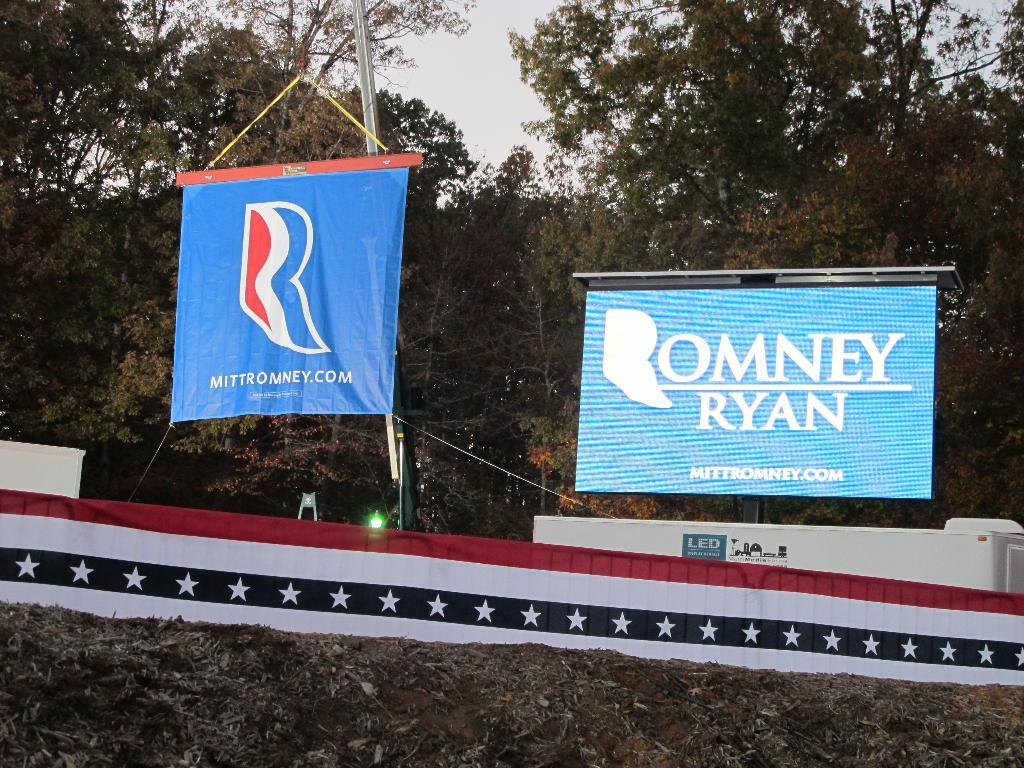<image>
Write a terse but informative summary of the picture. A blue sign showing support for Romney and Ryan is on top of stage. 